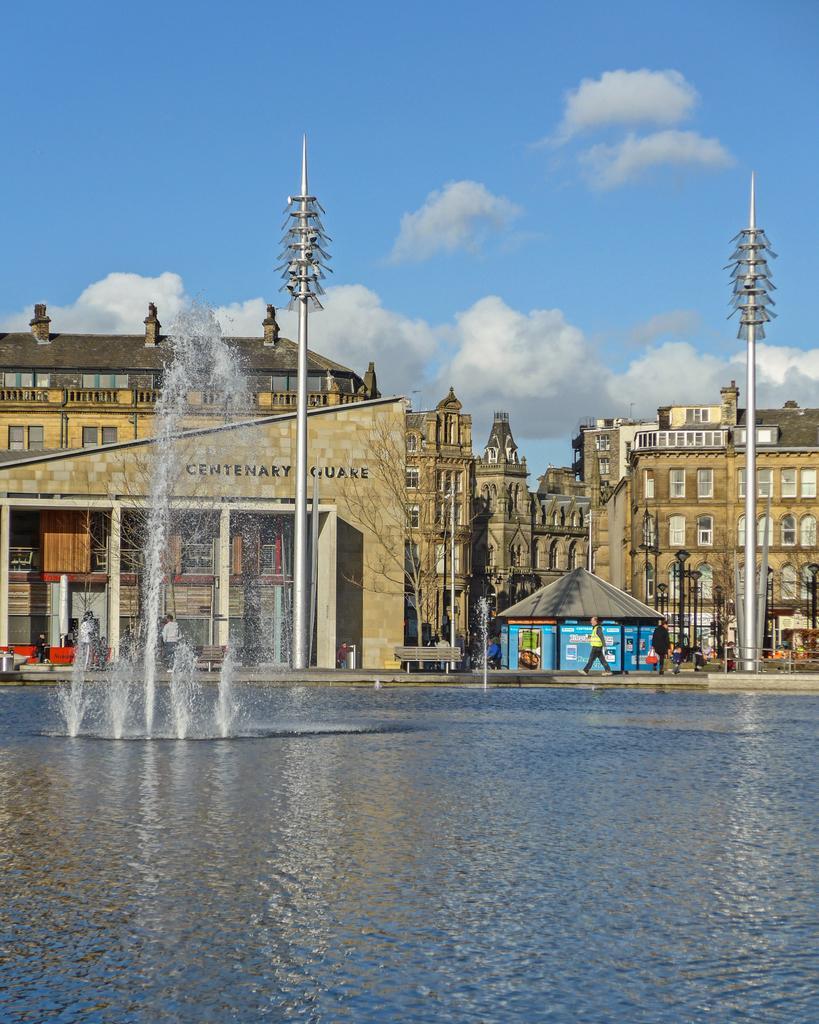Can you describe this image briefly? In this image I see the buildings and I see few people and I can also see few benches and I see the fountains and the water over here and I see 2 poles. In the background I see the sky which is of white and blue in color. 